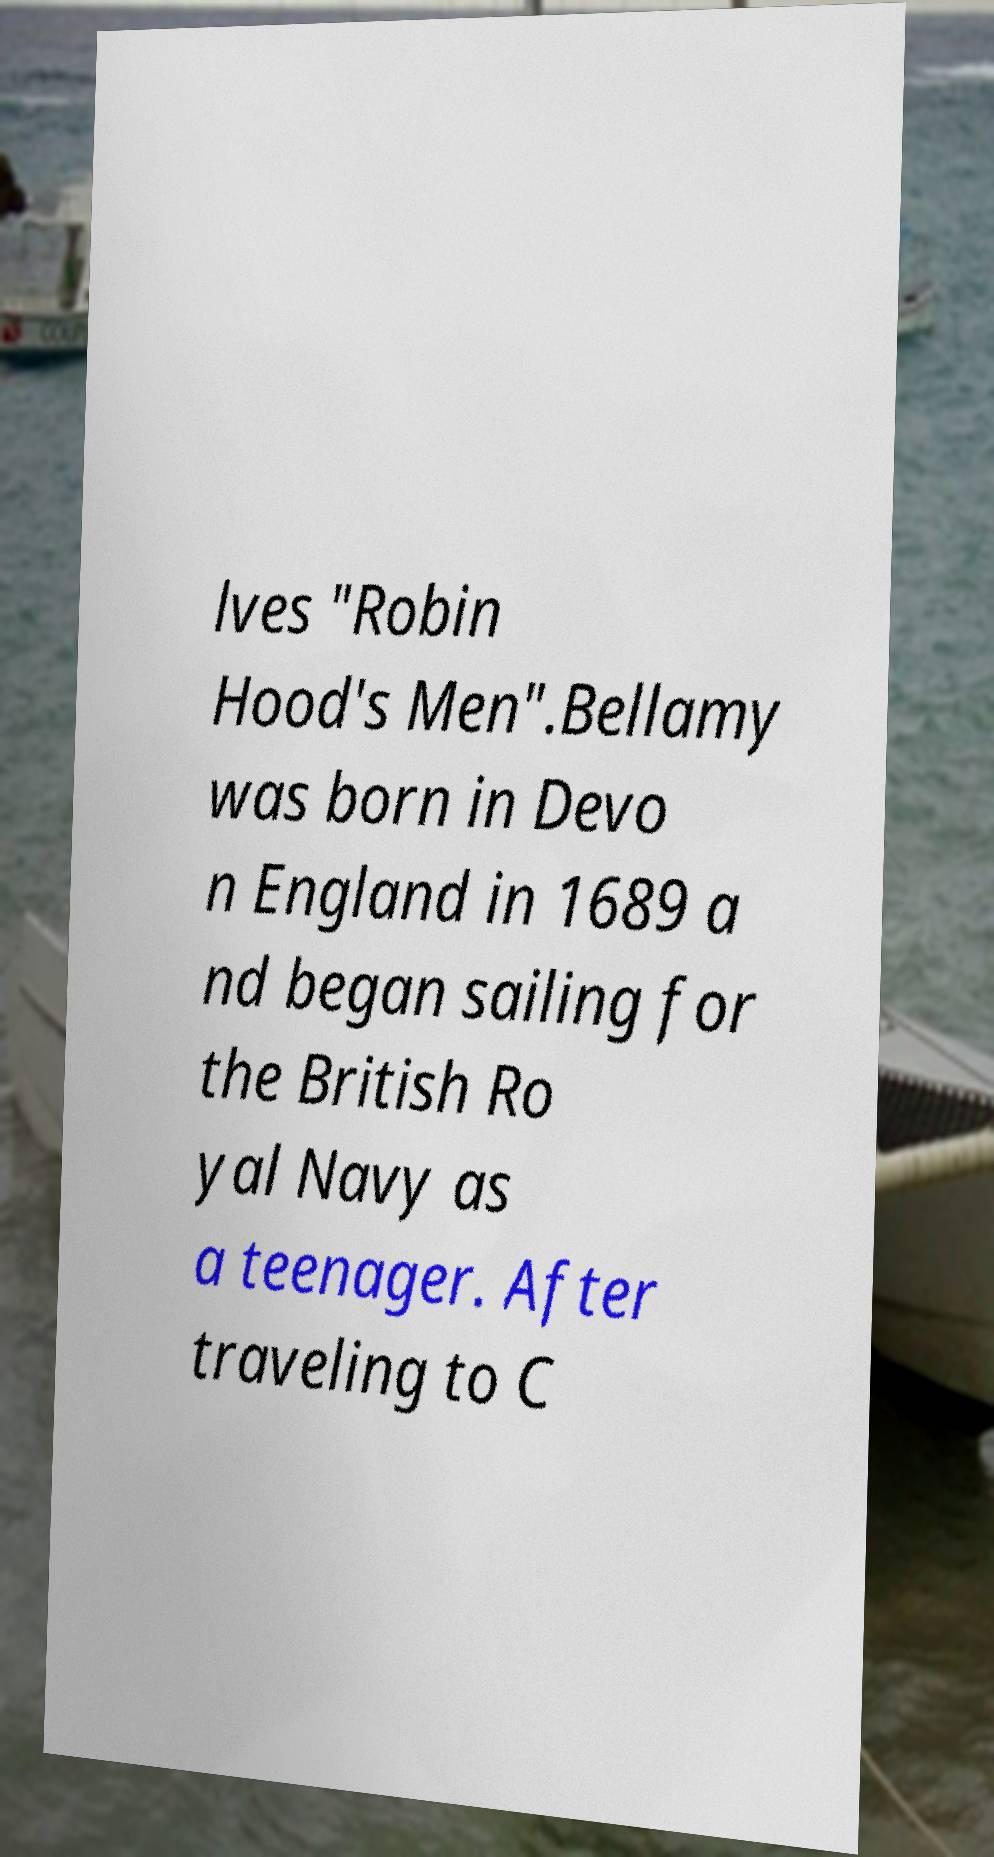Can you read and provide the text displayed in the image?This photo seems to have some interesting text. Can you extract and type it out for me? lves "Robin Hood's Men".Bellamy was born in Devo n England in 1689 a nd began sailing for the British Ro yal Navy as a teenager. After traveling to C 